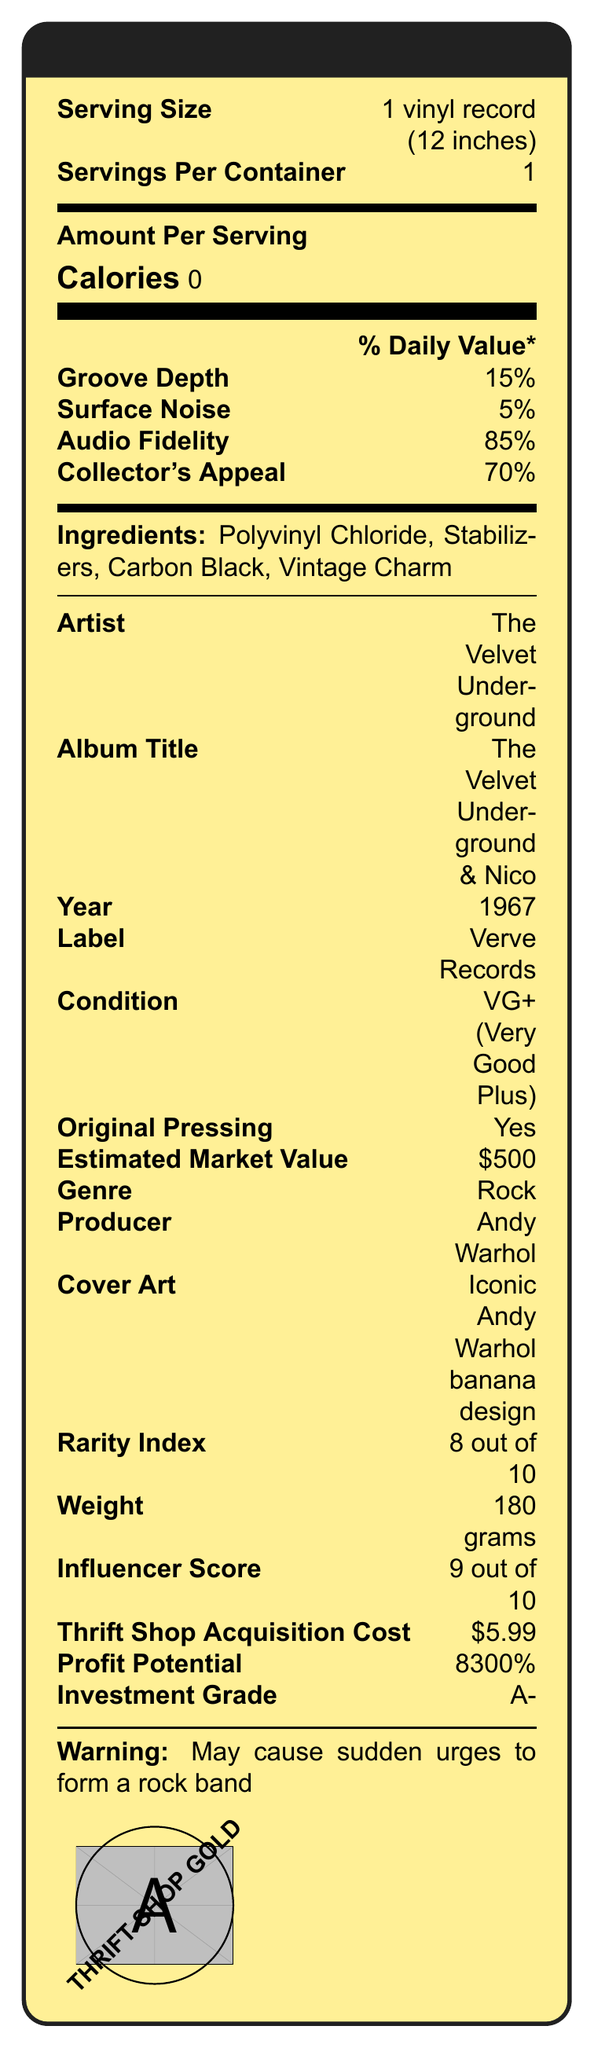What is the serving size? The document specifies that the serving size is 1 vinyl record (12 inches).
Answer: 1 vinyl record (12 inches) How many servings are there per container? The document states that there is 1 serving per container.
Answer: 1 What is the estimated market value of the vinyl record? The document lists the estimated market value as $500.
Answer: $500 Who produced the album? The document mentions that the producer of the album is Andy Warhol.
Answer: Andy Warhol What is the groove depth percentage mentioned in the document? The document shows that the groove depth is 15%.
Answer: 15% Which record label released this album? A. Capitol Records B. Verve Records C. Atlantic Records The document indicates that the album was released by Verve Records.
Answer: B What is the condition of this vinyl record? A. Mint B. Very Good Plus (VG+) C. Poor The document states that the condition of the vinyl record is VG+ (Very Good Plus).
Answer: B Is the vinyl record an original pressing? The document confirms that it is an original pressing.
Answer: Yes How much potential profit can be made if the vinyl is sold at its estimated market value? The percentage profit potential listed in the document is 8300%.
Answer: 8300% Summarize the main idea of the document. The document breaks down various characteristics of the vinyl record in a format similar to a Nutrition Facts label, detailing aspects like groove depth, surface noise, audio fidelity, and collector's appeal along with key details about the album and its significance.
Answer: The document provides detailed "Nutrition Facts" about a vintage vinyl record, including information on the artist, album title, year, label, condition, market value, and other assorted metrics related to audio quality, collector's appeal, and investment potential. What year was the album "The Velvet Underground & Nico" released? The document states that the album was released in 1967.
Answer: 1967 What is the weight of the vinyl record? The document lists the vinyl record's weight as 180 grams.
Answer: 180 grams What is the investment grade rating given in the document? The document rates the vinyl record with an investment grade of A-.
Answer: A- Describe the cover art of the album. The document details that the cover art features the iconic Andy Warhol banana design.
Answer: Iconic Andy Warhol banana design What is the matrix number for this vinyl record pressing? The document specifies the matrix number as MGS 679211.
Answer: MGS 679211 How many tracks are listed from the album? The document lists the tracks: "Sunday Morning," "I'm Waiting for the Man," "Femme Fatale," "Venus in Furs."
Answer: 4 Which pressing plant manufactured this vinyl record? Monarch Record Mfg. is listed as the pressing plant in the document.
Answer: Monarch Record Mfg. What is the thrift shop acquisition cost of this vinyl record? The document shows that the thrift shop acquisition cost was $5.99.
Answer: $5.99 What genre does this album belong to? The document classifies the album's genre as Rock.
Answer: Rock Does the document mention playback speed? The document mentions that the playback speed is 33 1/3 RPM.
Answer: Yes Is there any information about the historical or cultural significance of the album? The document notes that the album is "Highly influential in rock history."
Answer: Yes What is the total number of tracks on the album "The Velvet Underground & Nico"? The document lists only four tracks but does not provide the total number on the album.
Answer: Not enough information 